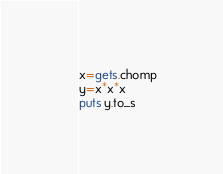Convert code to text. <code><loc_0><loc_0><loc_500><loc_500><_Ruby_>x=gets.chomp
y=x*x*x
puts y.to_s</code> 